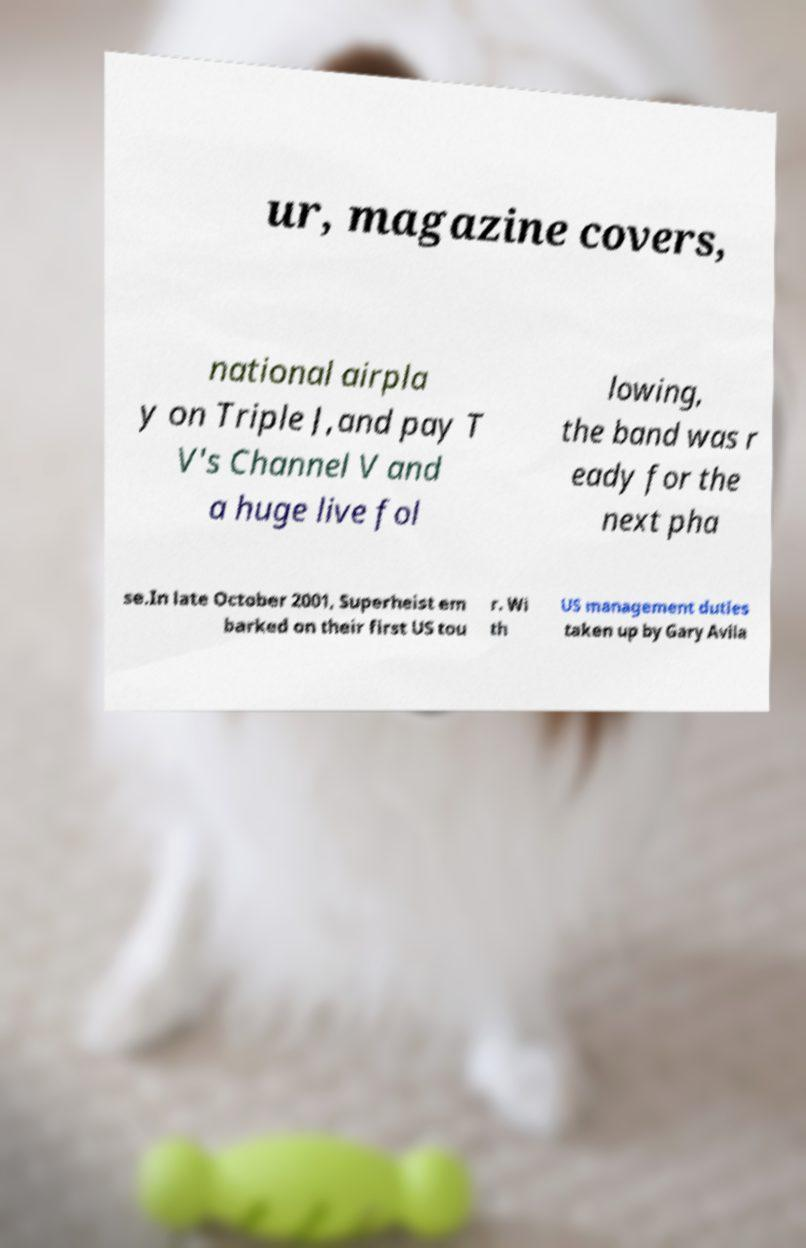Please identify and transcribe the text found in this image. ur, magazine covers, national airpla y on Triple J,and pay T V's Channel V and a huge live fol lowing, the band was r eady for the next pha se.In late October 2001, Superheist em barked on their first US tou r. Wi th US management duties taken up by Gary Avila 